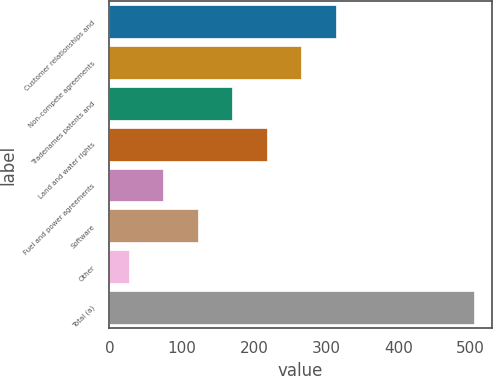Convert chart. <chart><loc_0><loc_0><loc_500><loc_500><bar_chart><fcel>Customer relationships and<fcel>Non-compete agreements<fcel>Tradenames patents and<fcel>Land and water rights<fcel>Fuel and power agreements<fcel>Software<fcel>Other<fcel>Total (a)<nl><fcel>313.2<fcel>265.5<fcel>170.1<fcel>217.8<fcel>74.7<fcel>122.4<fcel>27<fcel>504<nl></chart> 